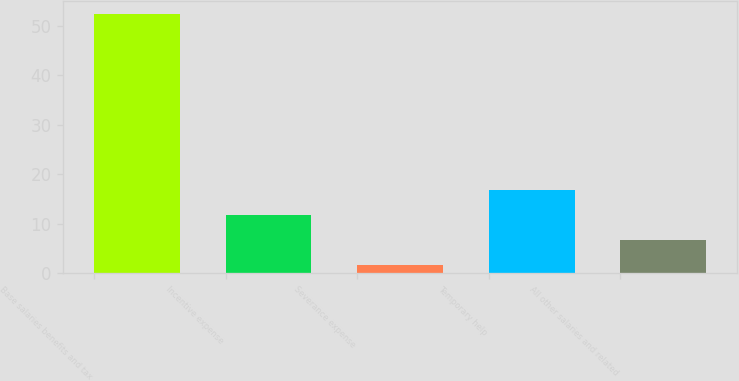Convert chart. <chart><loc_0><loc_0><loc_500><loc_500><bar_chart><fcel>Base salaries benefits and tax<fcel>Incentive expense<fcel>Severance expense<fcel>Temporary help<fcel>All other salaries and related<nl><fcel>52.3<fcel>11.74<fcel>1.6<fcel>16.81<fcel>6.67<nl></chart> 